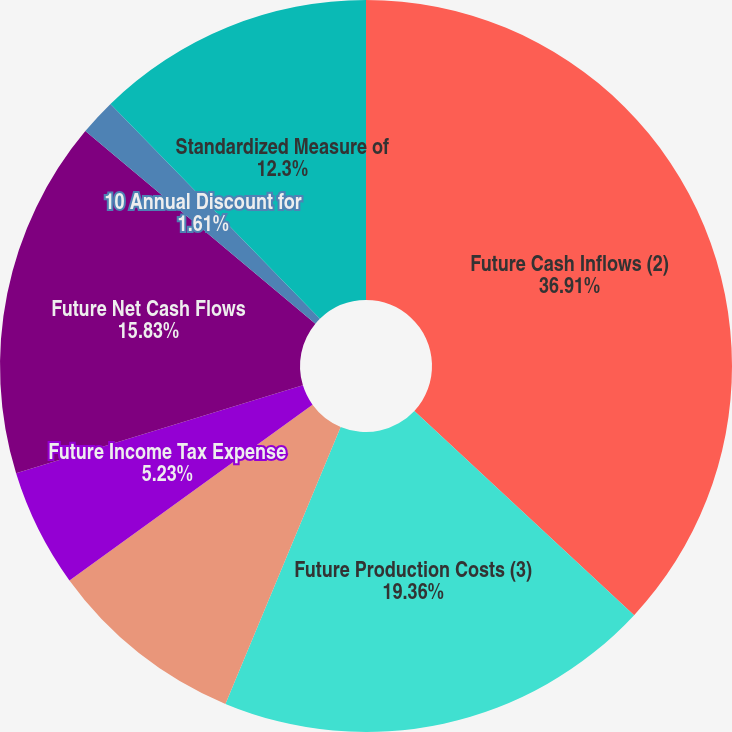Convert chart. <chart><loc_0><loc_0><loc_500><loc_500><pie_chart><fcel>Future Cash Inflows (2)<fcel>Future Production Costs (3)<fcel>Future Development Costs<fcel>Future Income Tax Expense<fcel>Future Net Cash Flows<fcel>10 Annual Discount for<fcel>Standardized Measure of<nl><fcel>36.92%<fcel>19.36%<fcel>8.76%<fcel>5.23%<fcel>15.83%<fcel>1.61%<fcel>12.3%<nl></chart> 